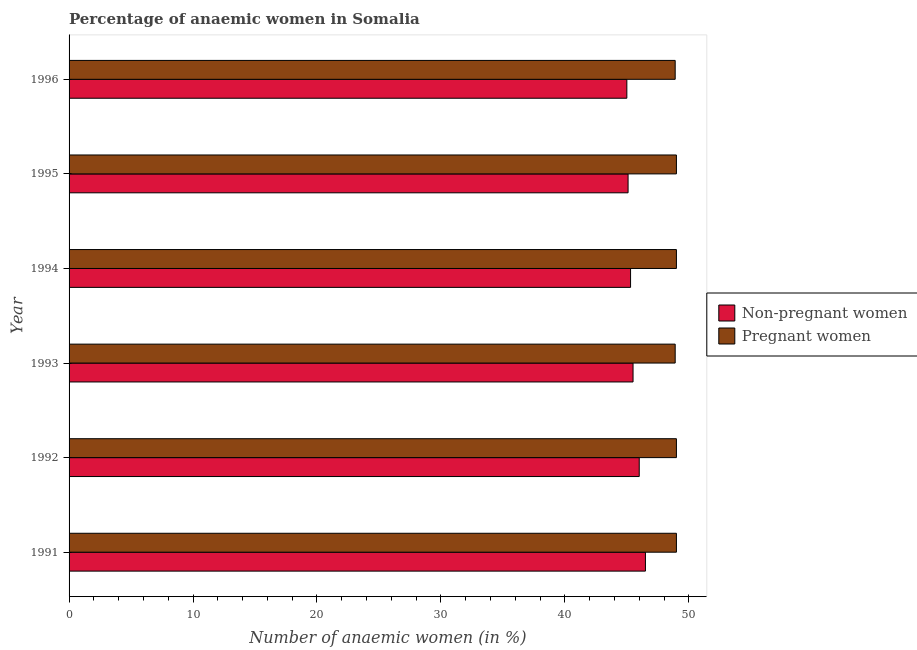How many different coloured bars are there?
Your answer should be very brief. 2. Are the number of bars per tick equal to the number of legend labels?
Your answer should be very brief. Yes. Are the number of bars on each tick of the Y-axis equal?
Offer a terse response. Yes. What is the percentage of non-pregnant anaemic women in 1996?
Your answer should be compact. 45. Across all years, what is the maximum percentage of non-pregnant anaemic women?
Keep it short and to the point. 46.5. Across all years, what is the minimum percentage of pregnant anaemic women?
Provide a short and direct response. 48.9. What is the total percentage of pregnant anaemic women in the graph?
Give a very brief answer. 293.8. What is the difference between the percentage of non-pregnant anaemic women in 1992 and that in 1996?
Your answer should be compact. 1. What is the difference between the percentage of non-pregnant anaemic women in 1994 and the percentage of pregnant anaemic women in 1995?
Offer a terse response. -3.7. What is the average percentage of non-pregnant anaemic women per year?
Your answer should be compact. 45.57. In how many years, is the percentage of pregnant anaemic women greater than 22 %?
Your response must be concise. 6. Is the difference between the percentage of pregnant anaemic women in 1992 and 1994 greater than the difference between the percentage of non-pregnant anaemic women in 1992 and 1994?
Ensure brevity in your answer.  No. What is the difference between the highest and the second highest percentage of non-pregnant anaemic women?
Ensure brevity in your answer.  0.5. What is the difference between the highest and the lowest percentage of non-pregnant anaemic women?
Your answer should be very brief. 1.5. In how many years, is the percentage of pregnant anaemic women greater than the average percentage of pregnant anaemic women taken over all years?
Your response must be concise. 4. Is the sum of the percentage of pregnant anaemic women in 1991 and 1995 greater than the maximum percentage of non-pregnant anaemic women across all years?
Provide a succinct answer. Yes. What does the 1st bar from the top in 1992 represents?
Offer a terse response. Pregnant women. What does the 2nd bar from the bottom in 1992 represents?
Keep it short and to the point. Pregnant women. Are all the bars in the graph horizontal?
Provide a short and direct response. Yes. What is the difference between two consecutive major ticks on the X-axis?
Your response must be concise. 10. Does the graph contain any zero values?
Provide a succinct answer. No. Does the graph contain grids?
Your answer should be compact. No. Where does the legend appear in the graph?
Ensure brevity in your answer.  Center right. How are the legend labels stacked?
Give a very brief answer. Vertical. What is the title of the graph?
Give a very brief answer. Percentage of anaemic women in Somalia. What is the label or title of the X-axis?
Your response must be concise. Number of anaemic women (in %). What is the label or title of the Y-axis?
Offer a very short reply. Year. What is the Number of anaemic women (in %) in Non-pregnant women in 1991?
Provide a succinct answer. 46.5. What is the Number of anaemic women (in %) in Non-pregnant women in 1993?
Keep it short and to the point. 45.5. What is the Number of anaemic women (in %) of Pregnant women in 1993?
Give a very brief answer. 48.9. What is the Number of anaemic women (in %) in Non-pregnant women in 1994?
Keep it short and to the point. 45.3. What is the Number of anaemic women (in %) in Pregnant women in 1994?
Your answer should be compact. 49. What is the Number of anaemic women (in %) of Non-pregnant women in 1995?
Offer a terse response. 45.1. What is the Number of anaemic women (in %) of Pregnant women in 1996?
Your answer should be very brief. 48.9. Across all years, what is the maximum Number of anaemic women (in %) of Non-pregnant women?
Offer a terse response. 46.5. Across all years, what is the maximum Number of anaemic women (in %) in Pregnant women?
Offer a terse response. 49. Across all years, what is the minimum Number of anaemic women (in %) in Pregnant women?
Offer a very short reply. 48.9. What is the total Number of anaemic women (in %) in Non-pregnant women in the graph?
Keep it short and to the point. 273.4. What is the total Number of anaemic women (in %) in Pregnant women in the graph?
Your answer should be very brief. 293.8. What is the difference between the Number of anaemic women (in %) in Pregnant women in 1991 and that in 1992?
Ensure brevity in your answer.  0. What is the difference between the Number of anaemic women (in %) in Pregnant women in 1991 and that in 1994?
Give a very brief answer. 0. What is the difference between the Number of anaemic women (in %) of Non-pregnant women in 1991 and that in 1995?
Provide a short and direct response. 1.4. What is the difference between the Number of anaemic women (in %) in Pregnant women in 1991 and that in 1995?
Make the answer very short. 0. What is the difference between the Number of anaemic women (in %) of Pregnant women in 1992 and that in 1993?
Offer a very short reply. 0.1. What is the difference between the Number of anaemic women (in %) of Non-pregnant women in 1992 and that in 1994?
Offer a very short reply. 0.7. What is the difference between the Number of anaemic women (in %) in Non-pregnant women in 1992 and that in 1995?
Ensure brevity in your answer.  0.9. What is the difference between the Number of anaemic women (in %) in Pregnant women in 1992 and that in 1995?
Your response must be concise. 0. What is the difference between the Number of anaemic women (in %) of Non-pregnant women in 1992 and that in 1996?
Provide a succinct answer. 1. What is the difference between the Number of anaemic women (in %) of Pregnant women in 1992 and that in 1996?
Your answer should be very brief. 0.1. What is the difference between the Number of anaemic women (in %) of Non-pregnant women in 1993 and that in 1994?
Provide a short and direct response. 0.2. What is the difference between the Number of anaemic women (in %) in Pregnant women in 1993 and that in 1994?
Provide a short and direct response. -0.1. What is the difference between the Number of anaemic women (in %) in Non-pregnant women in 1993 and that in 1995?
Make the answer very short. 0.4. What is the difference between the Number of anaemic women (in %) of Pregnant women in 1993 and that in 1996?
Keep it short and to the point. 0. What is the difference between the Number of anaemic women (in %) of Pregnant women in 1994 and that in 1995?
Give a very brief answer. 0. What is the difference between the Number of anaemic women (in %) of Non-pregnant women in 1991 and the Number of anaemic women (in %) of Pregnant women in 1993?
Provide a short and direct response. -2.4. What is the difference between the Number of anaemic women (in %) of Non-pregnant women in 1991 and the Number of anaemic women (in %) of Pregnant women in 1994?
Keep it short and to the point. -2.5. What is the difference between the Number of anaemic women (in %) in Non-pregnant women in 1991 and the Number of anaemic women (in %) in Pregnant women in 1995?
Offer a terse response. -2.5. What is the difference between the Number of anaemic women (in %) in Non-pregnant women in 1992 and the Number of anaemic women (in %) in Pregnant women in 1994?
Give a very brief answer. -3. What is the difference between the Number of anaemic women (in %) in Non-pregnant women in 1993 and the Number of anaemic women (in %) in Pregnant women in 1995?
Keep it short and to the point. -3.5. What is the difference between the Number of anaemic women (in %) of Non-pregnant women in 1995 and the Number of anaemic women (in %) of Pregnant women in 1996?
Provide a short and direct response. -3.8. What is the average Number of anaemic women (in %) in Non-pregnant women per year?
Your response must be concise. 45.57. What is the average Number of anaemic women (in %) in Pregnant women per year?
Ensure brevity in your answer.  48.97. In the year 1994, what is the difference between the Number of anaemic women (in %) in Non-pregnant women and Number of anaemic women (in %) in Pregnant women?
Give a very brief answer. -3.7. What is the ratio of the Number of anaemic women (in %) of Non-pregnant women in 1991 to that in 1992?
Give a very brief answer. 1.01. What is the ratio of the Number of anaemic women (in %) of Non-pregnant women in 1991 to that in 1993?
Your answer should be very brief. 1.02. What is the ratio of the Number of anaemic women (in %) of Pregnant women in 1991 to that in 1993?
Provide a succinct answer. 1. What is the ratio of the Number of anaemic women (in %) of Non-pregnant women in 1991 to that in 1994?
Offer a very short reply. 1.03. What is the ratio of the Number of anaemic women (in %) of Pregnant women in 1991 to that in 1994?
Your response must be concise. 1. What is the ratio of the Number of anaemic women (in %) of Non-pregnant women in 1991 to that in 1995?
Offer a terse response. 1.03. What is the ratio of the Number of anaemic women (in %) of Pregnant women in 1991 to that in 1995?
Give a very brief answer. 1. What is the ratio of the Number of anaemic women (in %) in Non-pregnant women in 1991 to that in 1996?
Provide a short and direct response. 1.03. What is the ratio of the Number of anaemic women (in %) of Non-pregnant women in 1992 to that in 1994?
Keep it short and to the point. 1.02. What is the ratio of the Number of anaemic women (in %) of Pregnant women in 1992 to that in 1994?
Ensure brevity in your answer.  1. What is the ratio of the Number of anaemic women (in %) in Non-pregnant women in 1992 to that in 1995?
Offer a terse response. 1.02. What is the ratio of the Number of anaemic women (in %) of Non-pregnant women in 1992 to that in 1996?
Provide a succinct answer. 1.02. What is the ratio of the Number of anaemic women (in %) in Pregnant women in 1992 to that in 1996?
Provide a succinct answer. 1. What is the ratio of the Number of anaemic women (in %) in Non-pregnant women in 1993 to that in 1994?
Ensure brevity in your answer.  1. What is the ratio of the Number of anaemic women (in %) in Non-pregnant women in 1993 to that in 1995?
Ensure brevity in your answer.  1.01. What is the ratio of the Number of anaemic women (in %) in Pregnant women in 1993 to that in 1995?
Your answer should be compact. 1. What is the ratio of the Number of anaemic women (in %) in Non-pregnant women in 1993 to that in 1996?
Provide a succinct answer. 1.01. What is the ratio of the Number of anaemic women (in %) in Pregnant women in 1993 to that in 1996?
Your answer should be very brief. 1. What is the ratio of the Number of anaemic women (in %) in Non-pregnant women in 1994 to that in 1995?
Give a very brief answer. 1. What is the difference between the highest and the second highest Number of anaemic women (in %) of Pregnant women?
Your answer should be compact. 0. What is the difference between the highest and the lowest Number of anaemic women (in %) of Pregnant women?
Keep it short and to the point. 0.1. 